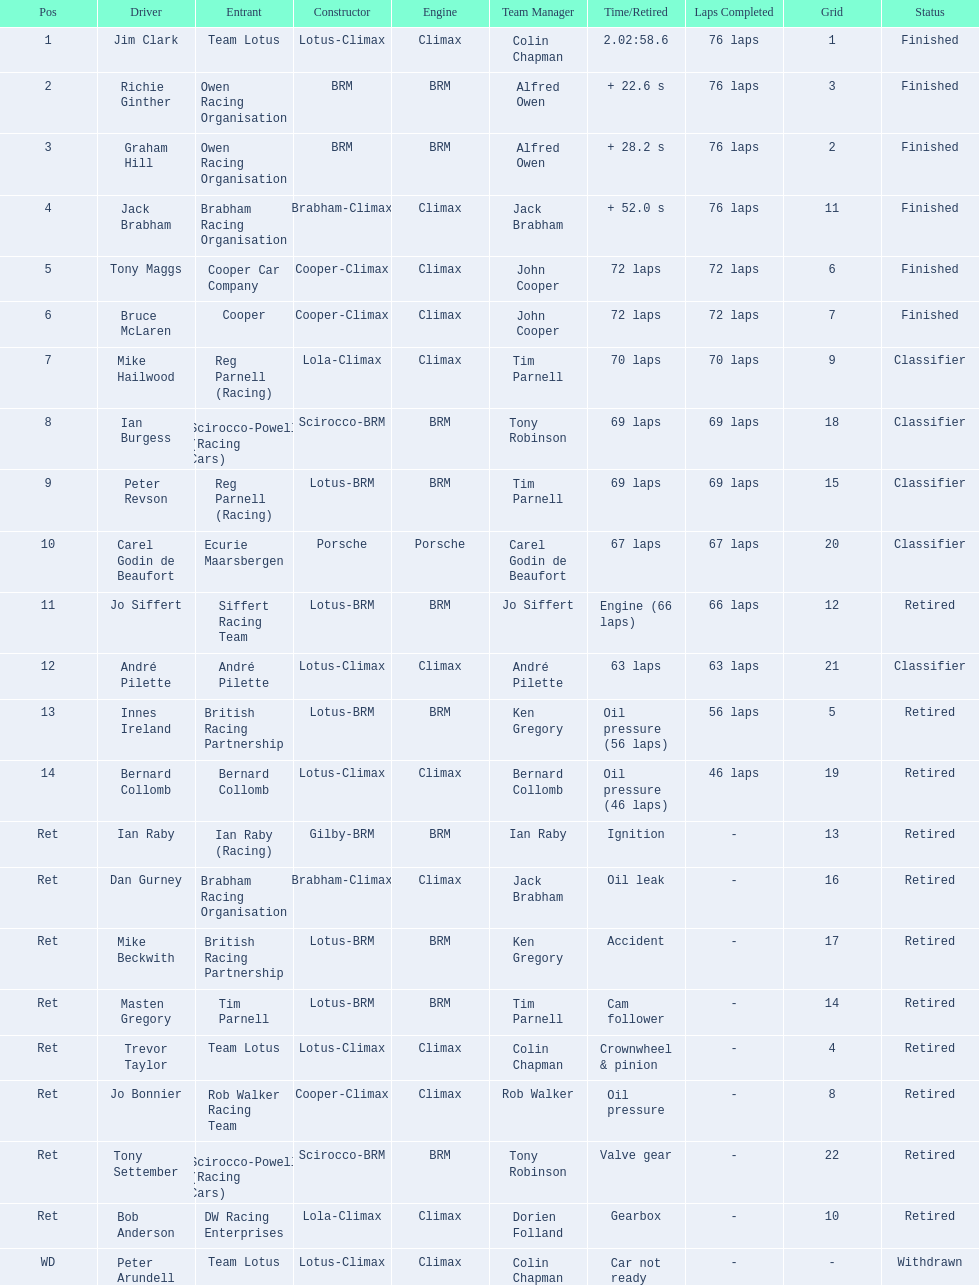What are the listed driver names? Jim Clark, Richie Ginther, Graham Hill, Jack Brabham, Tony Maggs, Bruce McLaren, Mike Hailwood, Ian Burgess, Peter Revson, Carel Godin de Beaufort, Jo Siffert, André Pilette, Innes Ireland, Bernard Collomb, Ian Raby, Dan Gurney, Mike Beckwith, Masten Gregory, Trevor Taylor, Jo Bonnier, Tony Settember, Bob Anderson, Peter Arundell. Which are tony maggs and jo siffert? Tony Maggs, Jo Siffert. What are their corresponding finishing places? 5, 11. Whose is better? Tony Maggs. 